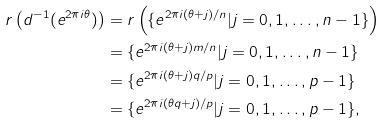<formula> <loc_0><loc_0><loc_500><loc_500>r \left ( d ^ { - 1 } ( e ^ { 2 \pi i \theta } ) \right ) & = r \left ( \{ e ^ { 2 \pi i ( \theta + j ) / n } | j = 0 , 1 , \dots , n - 1 \} \right ) \\ & = \{ e ^ { 2 \pi i ( \theta + j ) m / n } | j = 0 , 1 , \dots , n - 1 \} \\ & = \{ e ^ { 2 \pi i ( \theta + j ) q / p } | j = 0 , 1 , \dots , p - 1 \} \\ & = \{ e ^ { 2 \pi i ( \theta q + j ) / p } | j = 0 , 1 , \dots , p - 1 \} ,</formula> 